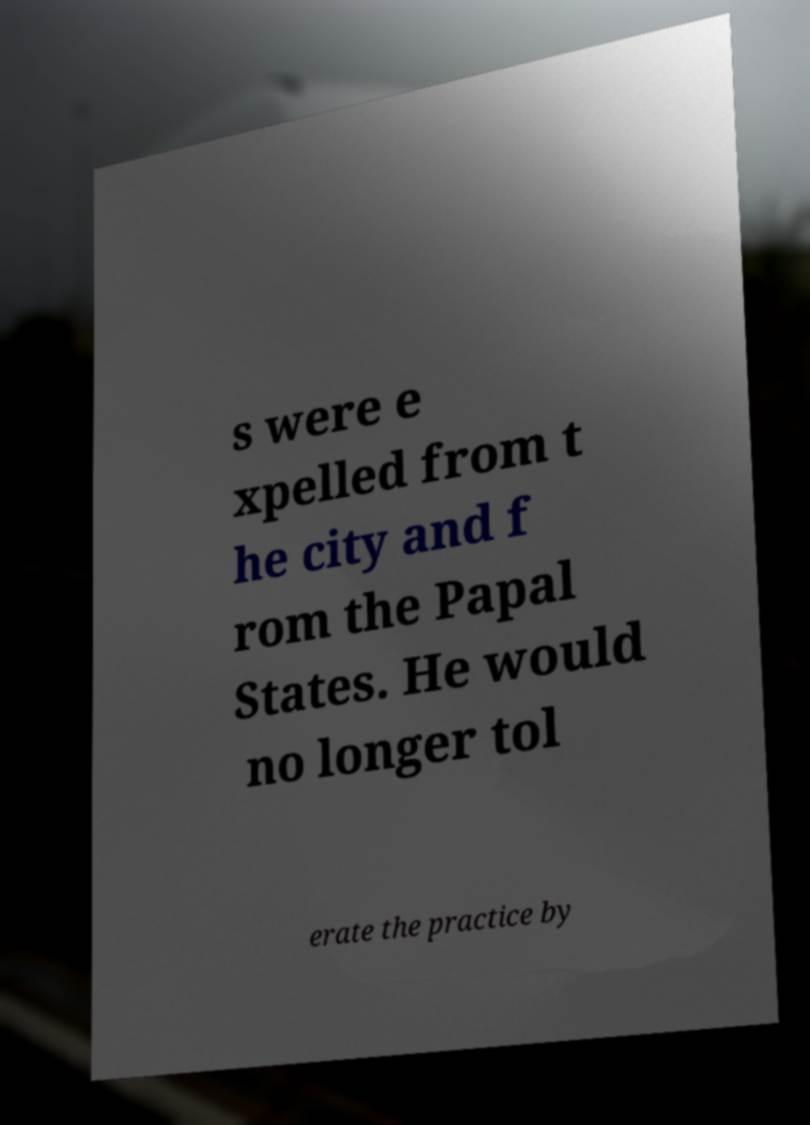I need the written content from this picture converted into text. Can you do that? s were e xpelled from t he city and f rom the Papal States. He would no longer tol erate the practice by 